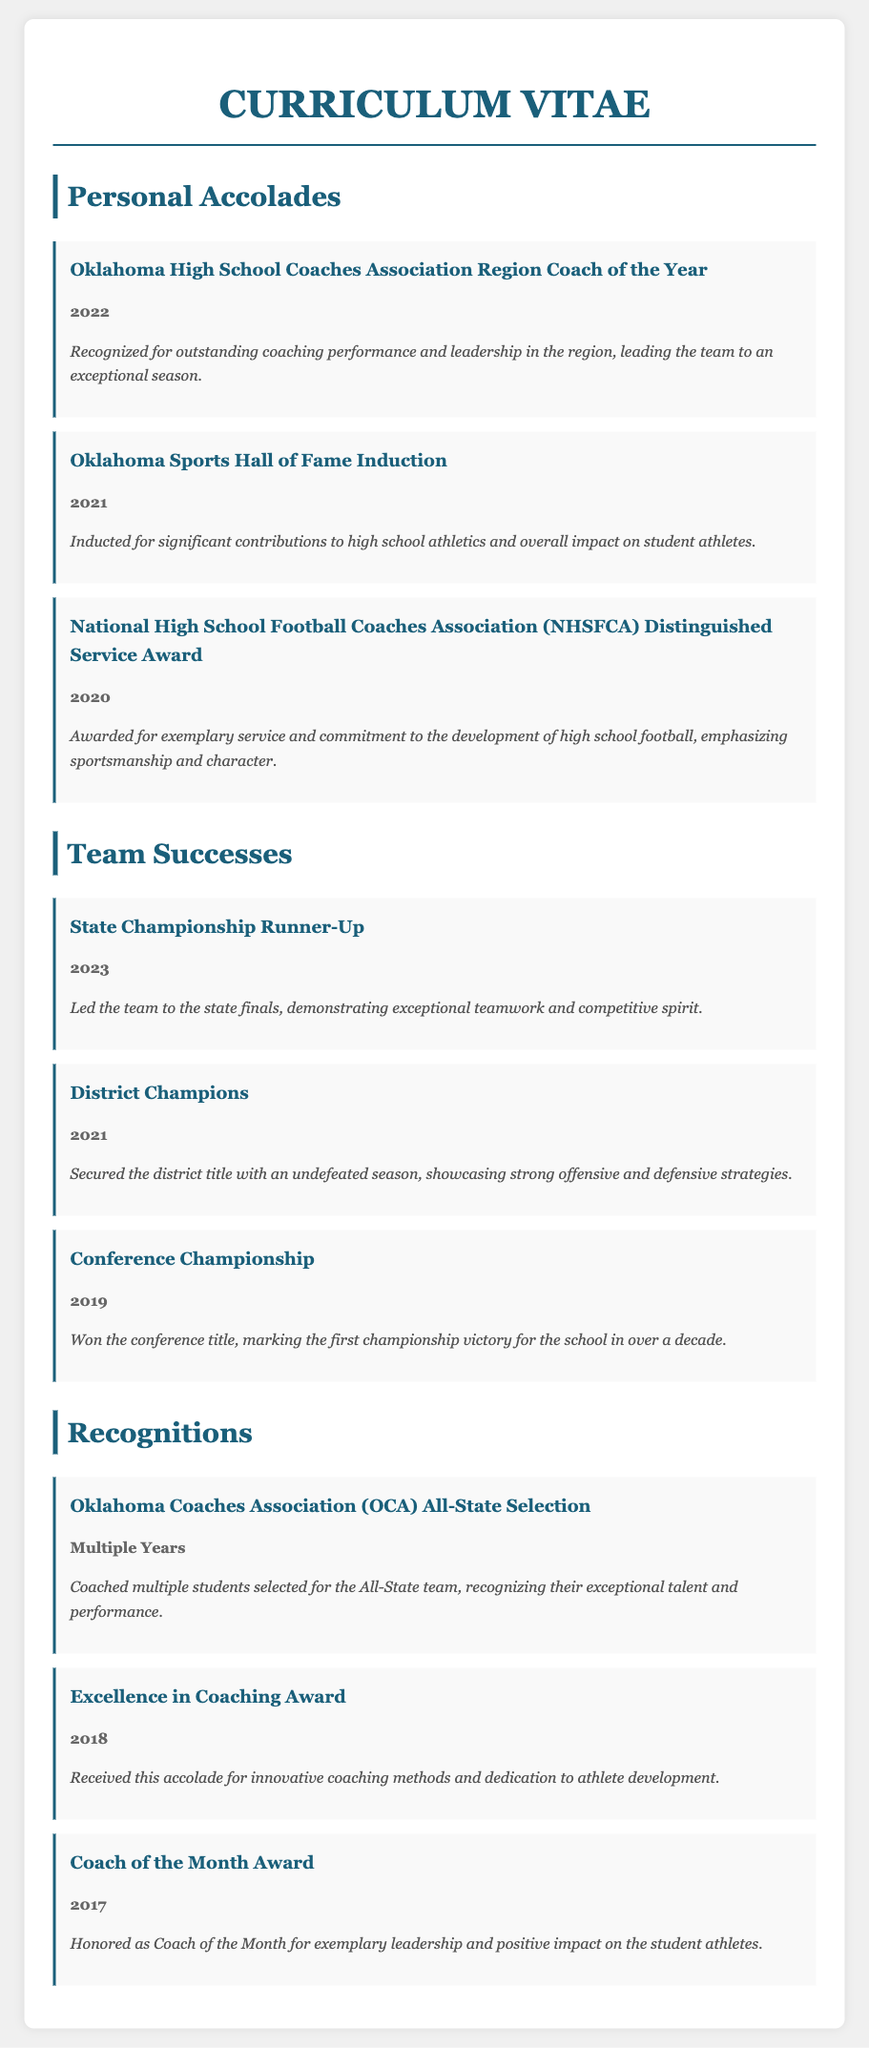What award did you receive in 2022? The document lists the "Oklahoma High School Coaches Association Region Coach of the Year" award received in 2022.
Answer: Oklahoma High School Coaches Association Region Coach of the Year Which team achievement occurred in 2023? The document states that the team was the "State Championship Runner-Up" in 2023.
Answer: State Championship Runner-Up What prestigious hall of fame recognition did you receive in 2021? In 2021, the document notes an induction into the "Oklahoma Sports Hall of Fame."
Answer: Oklahoma Sports Hall of Fame How many years did you coach students selected for the All-State team? The document indicates this accomplishment happened in "Multiple Years," referring to various years of selections.
Answer: Multiple Years What award did you receive for coaching excellence in 2018? The curriculum vitae mentions the "Excellence in Coaching Award" received in 2018.
Answer: Excellence in Coaching Award What team title did your team achieve in 2021? According to the document, the team won the title of "District Champions" in 2021.
Answer: District Champions What is the first championship victory year mentioned for the conference title? The document identifies the year of the "Conference Championship" as 2019, marking over a decade since the last victory.
Answer: 2019 What type of recognition did you receive in 2017? The document states you were honored with the "Coach of the Month Award" in 2017.
Answer: Coach of the Month Award What is a common theme among the awards and recognitions mentioned? The document highlights themes of coaching excellence, leadership, and athlete development through various awards.
Answer: Coaching excellence, leadership, and athlete development 